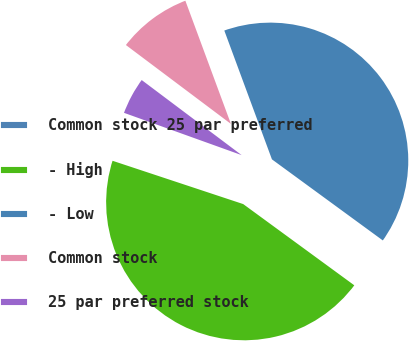Convert chart to OTSL. <chart><loc_0><loc_0><loc_500><loc_500><pie_chart><fcel>Common stock 25 par preferred<fcel>- High<fcel>- Low<fcel>Common stock<fcel>25 par preferred stock<nl><fcel>0.4%<fcel>45.04%<fcel>40.68%<fcel>9.11%<fcel>4.76%<nl></chart> 